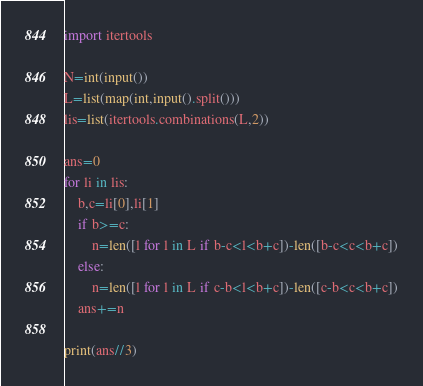<code> <loc_0><loc_0><loc_500><loc_500><_Python_>import itertools

N=int(input())
L=list(map(int,input().split()))
lis=list(itertools.combinations(L,2))

ans=0
for li in lis:
    b,c=li[0],li[1]
    if b>=c:
        n=len([l for l in L if b-c<l<b+c])-len([b-c<c<b+c])
    else:
        n=len([l for l in L if c-b<l<b+c])-len([c-b<c<b+c])
    ans+=n
    
print(ans//3)</code> 